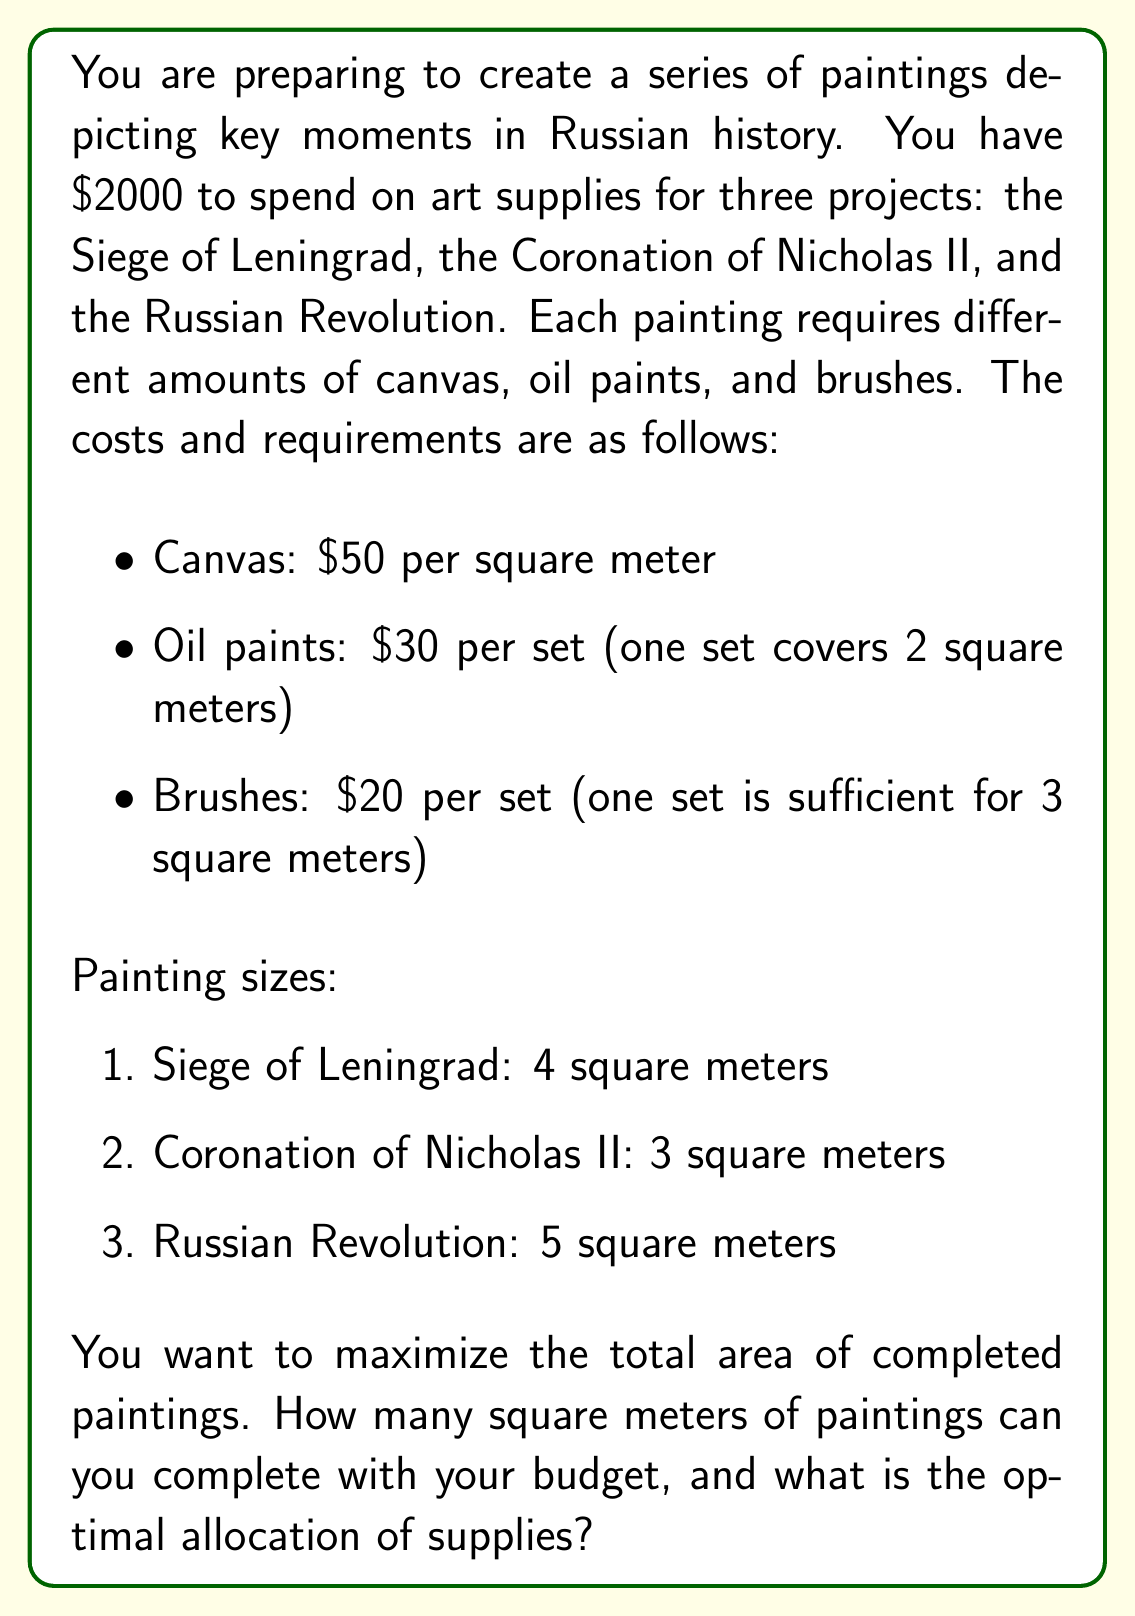Solve this math problem. Let's approach this step-by-step using linear programming:

1) Define variables:
   Let $x_1$, $x_2$, and $x_3$ be the areas (in square meters) of the Siege of Leningrad, Coronation of Nicholas II, and Russian Revolution paintings, respectively.

2) Objective function:
   We want to maximize the total area: $\max(x_1 + x_2 + x_3)$

3) Constraints:
   a) Budget constraint:
      Cost of canvas: $50(x_1 + x_2 + x_3)$
      Cost of paint: $30 \cdot \frac{x_1 + x_2 + x_3}{2}$ = $15(x_1 + x_2 + x_3)$
      Cost of brushes: $20 \cdot \frac{x_1 + x_2 + x_3}{3}$ = $\frac{20}{3}(x_1 + x_2 + x_3)$
      Total cost: $50x_1 + 50x_2 + 50x_3 + 15x_1 + 15x_2 + 15x_3 + \frac{20}{3}x_1 + \frac{20}{3}x_2 + \frac{20}{3}x_3 \leq 2000$
      Simplifying: $\frac{215}{3}(x_1 + x_2 + x_3) \leq 2000$

   b) Size constraints:
      $x_1 \leq 4$
      $x_2 \leq 3$
      $x_3 \leq 5$

   c) Non-negativity:
      $x_1, x_2, x_3 \geq 0$

4) Solving:
   From the budget constraint: $x_1 + x_2 + x_3 \leq \frac{2000 \cdot 3}{215} \approx 27.91$
   
   This means we can paint a maximum of 27.91 square meters in total.

   Given the size constraints, the optimal solution is:
   $x_1 = 4$, $x_2 = 3$, $x_3 = 5$

   Total area: $4 + 3 + 5 = 12$ square meters

5) Checking the budget:
   $\frac{215}{3} \cdot 12 = 860$, which is less than $2000

Therefore, you can complete all three paintings in their full sizes.
Answer: You can complete 12 square meters of paintings. The optimal allocation is to complete all three paintings at their full sizes: 4 square meters for the Siege of Leningrad, 3 square meters for the Coronation of Nicholas II, and 5 square meters for the Russian Revolution. 